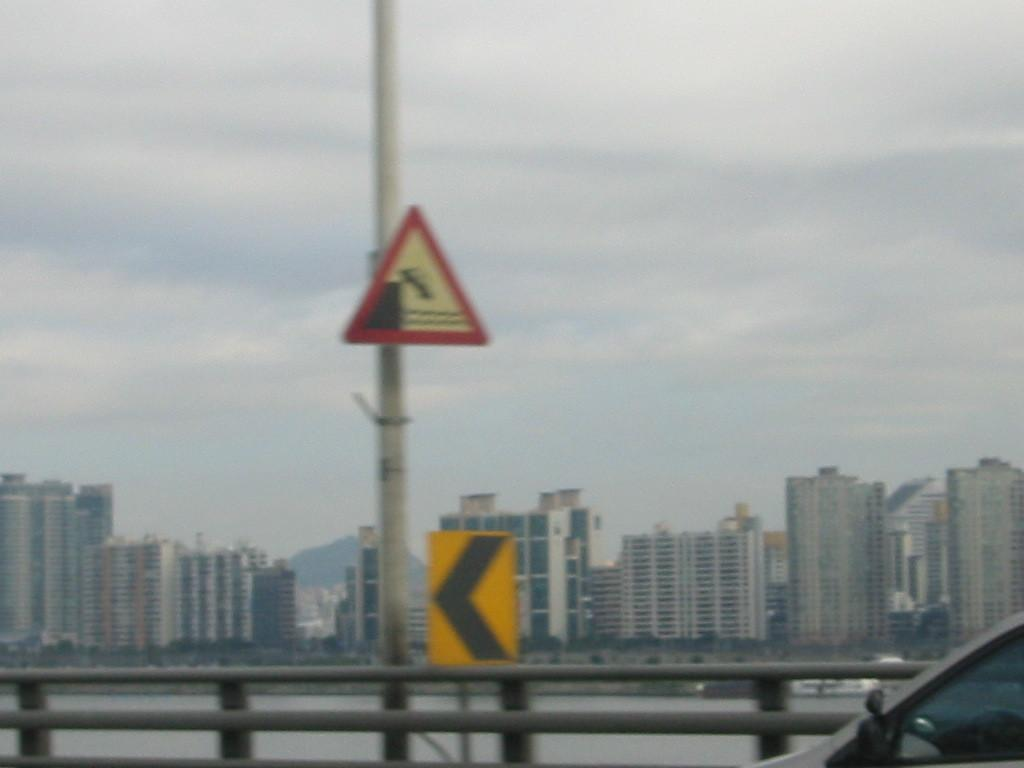What is on the pole in the image? There is a sign board on the pole in the image. What else is near the pole? There is another board near the pole. What can be seen on the ground in the image? There are roads visible in the image. What is visible in the background of the image? There is water, buildings, and the sky visible in the background of the image. What type of wall can be seen in the image? There is no wall present in the image. --- Facts: 1. There is a person in the image. 2. The person is wearing a hat. 3. The person is holding a book. 4. The person is standing in front of a bookshelf. 5. The bookshelf is filled with books. Absurd Topics: elephant, piano Conversation: Who or what is in the image? There is a person in the image. What is the person wearing? The person is wearing a hat. What is the person holding? The person is holding a book. What is behind the person? The person is standing in front of a bookshelf. How are the bookshelf filled? The bookshelf is filled with books. Reasoning: Let's think step by step in order to produce the conversation. We start by identifying the main subject of the image, which is the person. Then, we describe specific features of the person, such as the hat and the book they are holding. Next, we observe the person's surroundings, noting that they are standing in front of a bookshelf. Finally, we describe the bookshelf's contents, which are filled with books. Absurd Question/Answer: What type of elephant can be seen playing the piano in the image? There is no elephant or piano present in the image. 